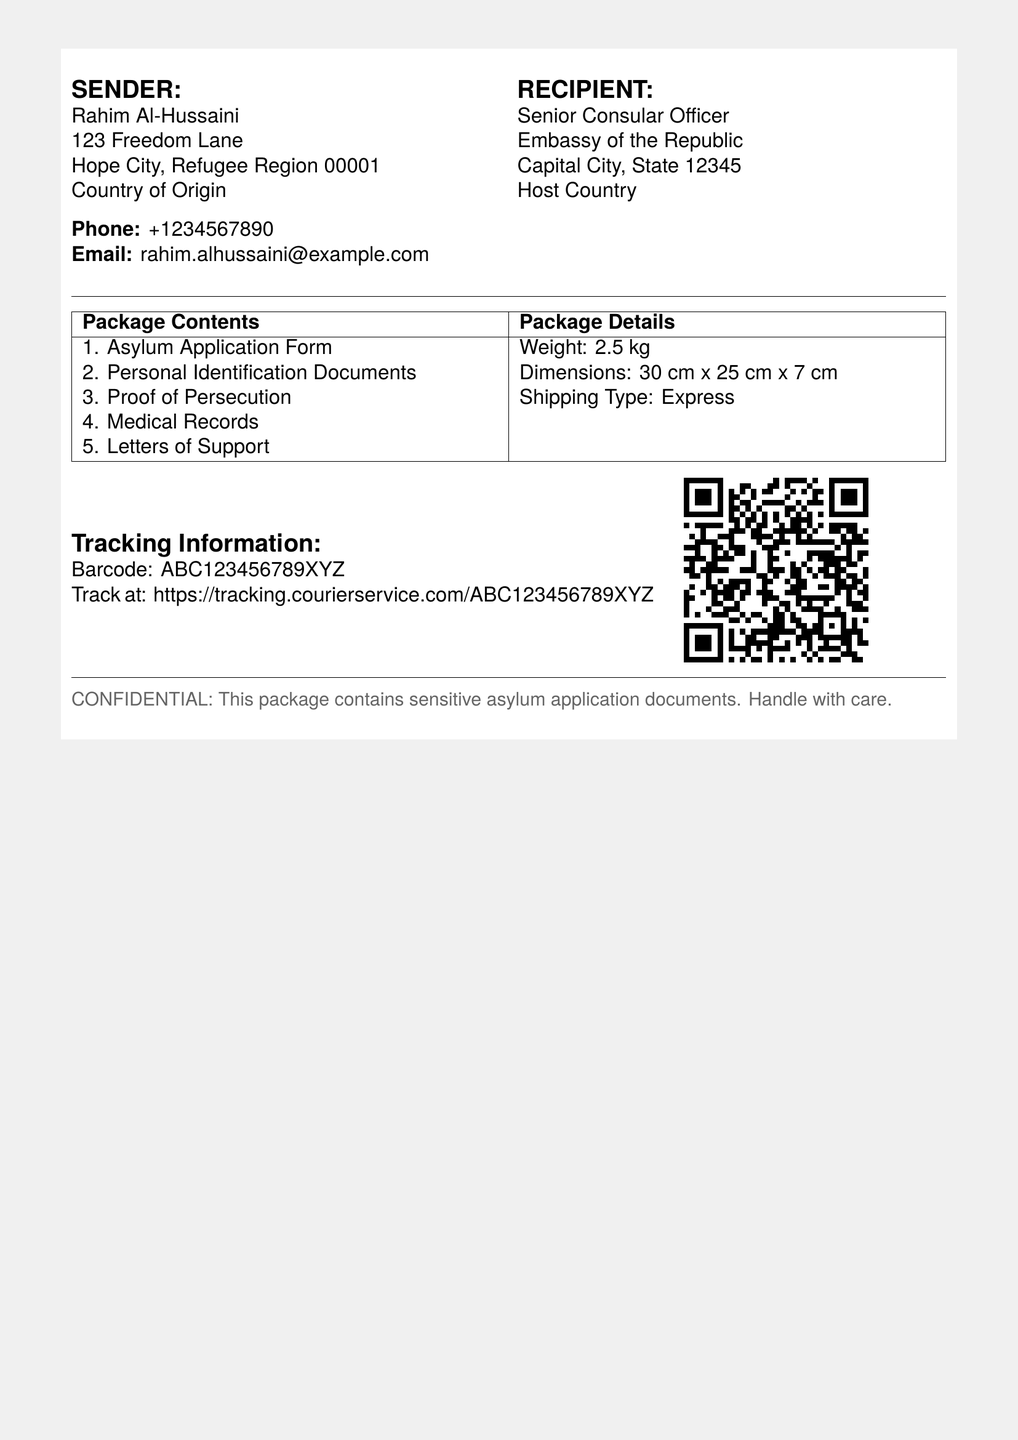What is the name of the sender? The sender's name is presented in the document as the first line under the sender section.
Answer: Rahim Al-Hussaini What is the phone number of the sender? The sender's phone number is listed under the sender information.
Answer: +1234567890 What is the weight of the package? The weight of the package is specified in the package details table.
Answer: 2.5 kg Who is the recipient of the package? The recipient's title and organization are indicated at the top of the recipient section.
Answer: Senior Consular Officer What documents are included as contents of the package? The contents are listed in a numbered format under the package contents section.
Answer: Asylum Application Form, Personal Identification Documents, Proof of Persecution, Medical Records, Letters of Support What type of shipping is being used? The type of shipping is mentioned in the package details section along with other package information.
Answer: Express What is the tracking barcode for this package? The tracking barcode is provided in the tracking information area.
Answer: ABC123456789XYZ How can one track the package? The document provides a tracking URL for more details on the tracking information.
Answer: https://tracking.courierservice.com/ABC123456789XYZ What is indicated in the confidentiality notice? The confidentiality notice is present at the bottom of the document regarding package content.
Answer: Handle with care 